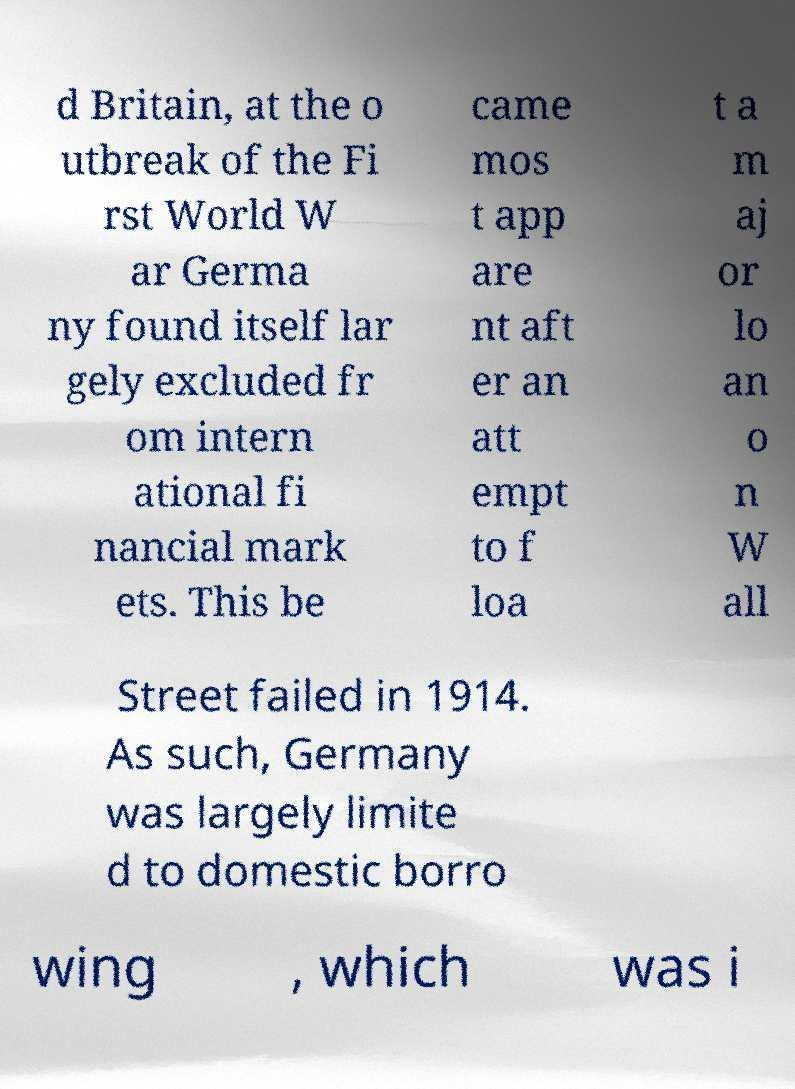Please read and relay the text visible in this image. What does it say? d Britain, at the o utbreak of the Fi rst World W ar Germa ny found itself lar gely excluded fr om intern ational fi nancial mark ets. This be came mos t app are nt aft er an att empt to f loa t a m aj or lo an o n W all Street failed in 1914. As such, Germany was largely limite d to domestic borro wing , which was i 